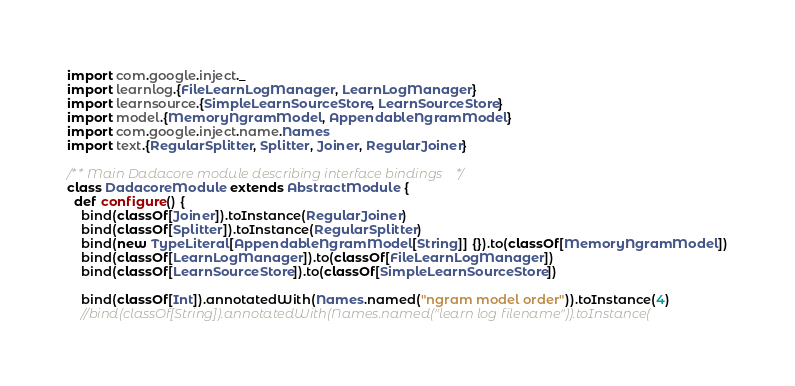Convert code to text. <code><loc_0><loc_0><loc_500><loc_500><_Scala_>
import com.google.inject._
import learnlog.{FileLearnLogManager, LearnLogManager}
import learnsource.{SimpleLearnSourceStore, LearnSourceStore}
import model.{MemoryNgramModel, AppendableNgramModel}
import com.google.inject.name.Names
import text.{RegularSplitter, Splitter, Joiner, RegularJoiner}

/** Main Dadacore module describing interface bindings */
class DadacoreModule extends AbstractModule {
  def configure() {
    bind(classOf[Joiner]).toInstance(RegularJoiner)
    bind(classOf[Splitter]).toInstance(RegularSplitter)
    bind(new TypeLiteral[AppendableNgramModel[String]] {}).to(classOf[MemoryNgramModel])
    bind(classOf[LearnLogManager]).to(classOf[FileLearnLogManager])
    bind(classOf[LearnSourceStore]).to(classOf[SimpleLearnSourceStore])

    bind(classOf[Int]).annotatedWith(Names.named("ngram model order")).toInstance(4)
    //bind(classOf[String]).annotatedWith(Names.named("learn log filename")).toInstance(</code> 